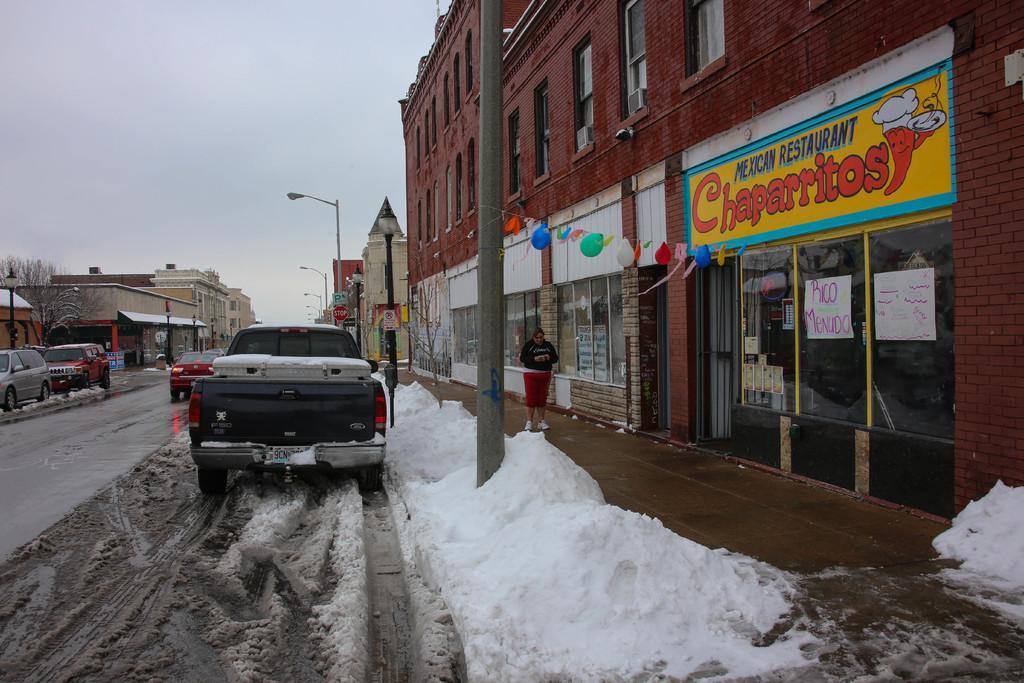Describe this image in one or two sentences. In this image, we can see a road in between buildings. There are vehicles on the road. There is a snow at the bottom of the image. There are poles beside the road. There is a person in front of the building. There is a sky at the top of the image. 